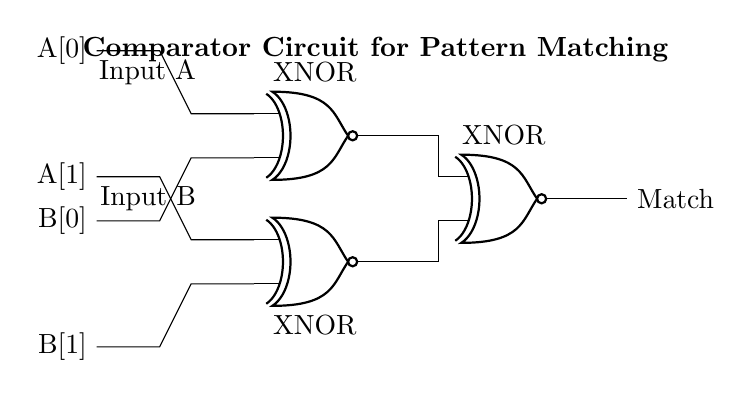What type of circuit is displayed? The circuit shown is a comparator circuit, which compares two inputs to determine if they match. It uses XNOR gates to perform this function.
Answer: Comparator How many inputs does this circuit have? The circuit has two inputs: A and B, each of which has two bits (A[0], A[1] and B[0], B[1]).
Answer: Two What is the output of the circuit? The output of the circuit is labeled as "Match", indicating whether the inputs match after processing through the XNOR gates.
Answer: Match What logic gate is used in this circuit? The circuit utilizes XNOR gates, which output true if the number of true inputs is even, primarily focusing on matching bits.
Answer: XNOR What is the function of the first XNOR gate? The first XNOR gate compares the least significant bits (A[0] and B[0]) to see if they are equal.
Answer: Comparison of A[0] and B[0] How does the final output indicate a match? The final output from the third XNOR gate shows "Match" if both pairs of inputs (A[0], B[0] and A[1], B[1]) are the same, as both XNOR gates must output true for this to happen.
Answer: It indicates a match when both previous XNOR gates output true What do the labeled inputs signify in the diagram? The labeled inputs A[0], A[1], B[0], and B[1] signify the two bits of information from the two input sequences being compared for pattern matching.
Answer: They represent the input bits 